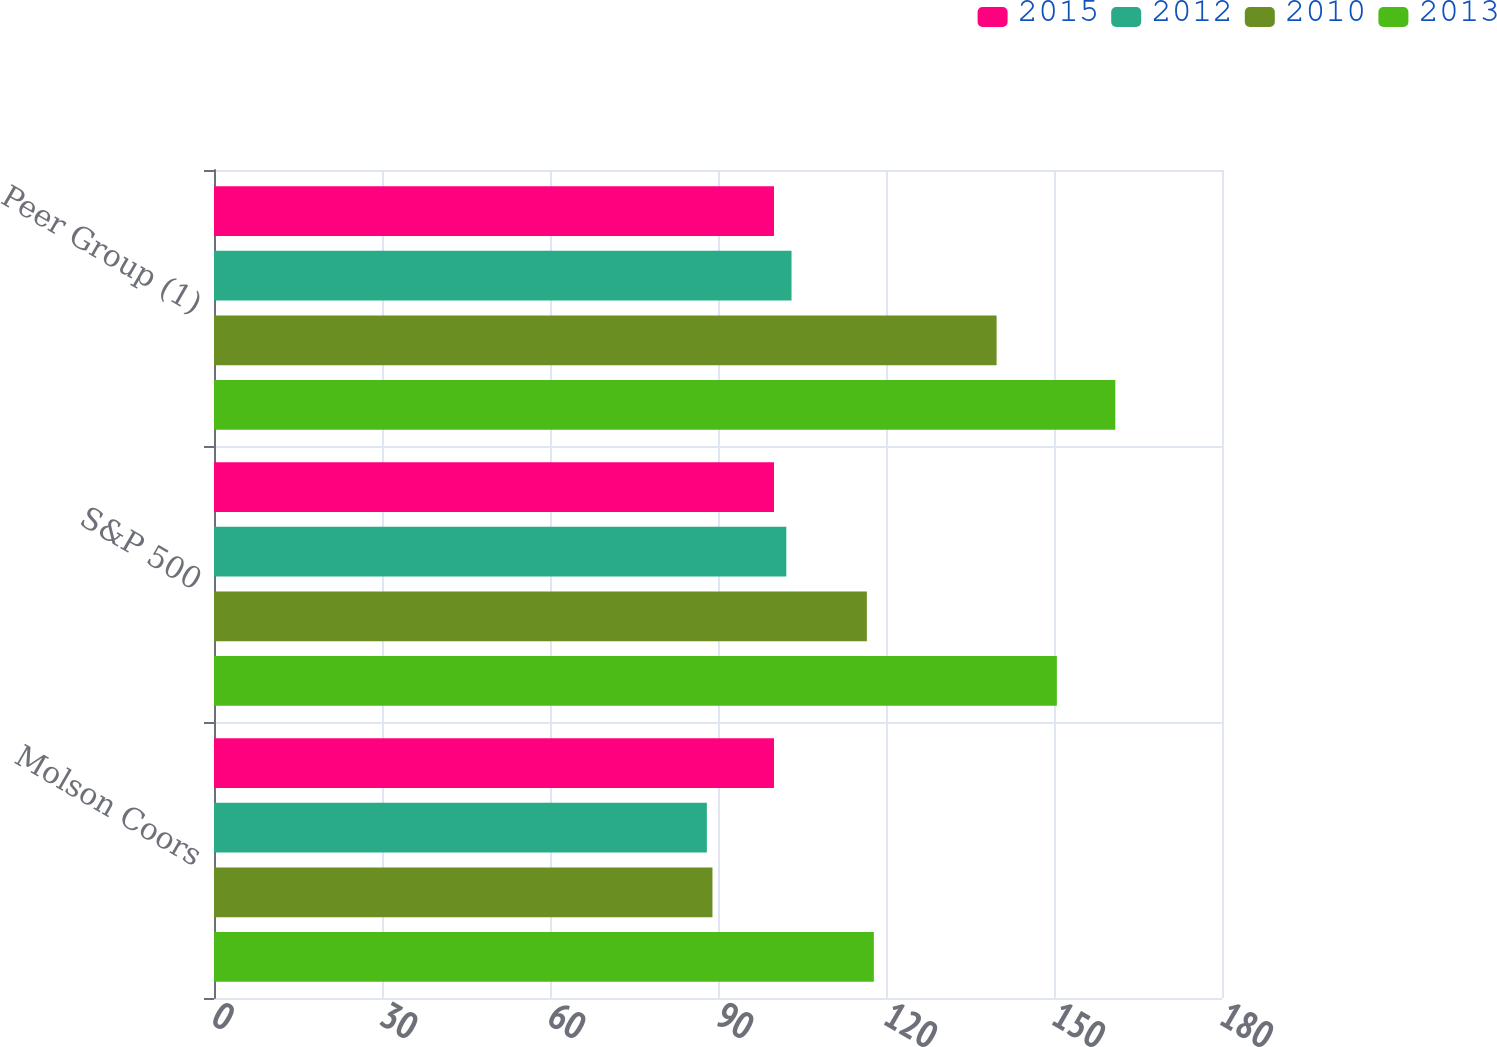Convert chart. <chart><loc_0><loc_0><loc_500><loc_500><stacked_bar_chart><ecel><fcel>Molson Coors<fcel>S&P 500<fcel>Peer Group (1)<nl><fcel>2015<fcel>100<fcel>100<fcel>100<nl><fcel>2012<fcel>88.01<fcel>102.2<fcel>103.13<nl><fcel>2010<fcel>89.01<fcel>116.58<fcel>139.75<nl><fcel>2013<fcel>117.83<fcel>150.51<fcel>160.95<nl></chart> 